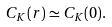Convert formula to latex. <formula><loc_0><loc_0><loc_500><loc_500>C _ { K } ( r ) \simeq C _ { K } ( 0 ) .</formula> 